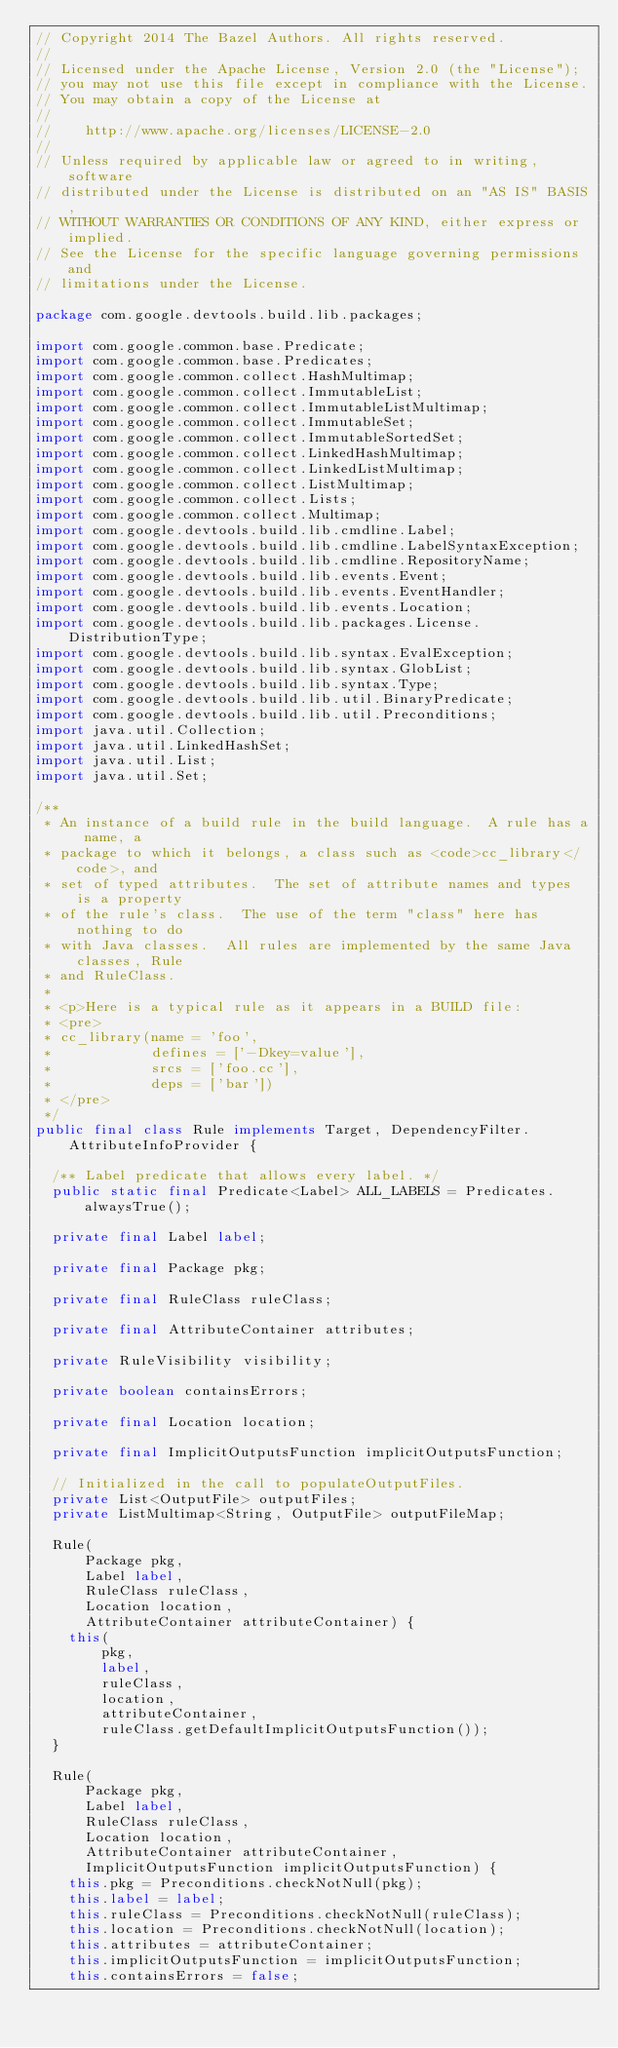Convert code to text. <code><loc_0><loc_0><loc_500><loc_500><_Java_>// Copyright 2014 The Bazel Authors. All rights reserved.
//
// Licensed under the Apache License, Version 2.0 (the "License");
// you may not use this file except in compliance with the License.
// You may obtain a copy of the License at
//
//    http://www.apache.org/licenses/LICENSE-2.0
//
// Unless required by applicable law or agreed to in writing, software
// distributed under the License is distributed on an "AS IS" BASIS,
// WITHOUT WARRANTIES OR CONDITIONS OF ANY KIND, either express or implied.
// See the License for the specific language governing permissions and
// limitations under the License.

package com.google.devtools.build.lib.packages;

import com.google.common.base.Predicate;
import com.google.common.base.Predicates;
import com.google.common.collect.HashMultimap;
import com.google.common.collect.ImmutableList;
import com.google.common.collect.ImmutableListMultimap;
import com.google.common.collect.ImmutableSet;
import com.google.common.collect.ImmutableSortedSet;
import com.google.common.collect.LinkedHashMultimap;
import com.google.common.collect.LinkedListMultimap;
import com.google.common.collect.ListMultimap;
import com.google.common.collect.Lists;
import com.google.common.collect.Multimap;
import com.google.devtools.build.lib.cmdline.Label;
import com.google.devtools.build.lib.cmdline.LabelSyntaxException;
import com.google.devtools.build.lib.cmdline.RepositoryName;
import com.google.devtools.build.lib.events.Event;
import com.google.devtools.build.lib.events.EventHandler;
import com.google.devtools.build.lib.events.Location;
import com.google.devtools.build.lib.packages.License.DistributionType;
import com.google.devtools.build.lib.syntax.EvalException;
import com.google.devtools.build.lib.syntax.GlobList;
import com.google.devtools.build.lib.syntax.Type;
import com.google.devtools.build.lib.util.BinaryPredicate;
import com.google.devtools.build.lib.util.Preconditions;
import java.util.Collection;
import java.util.LinkedHashSet;
import java.util.List;
import java.util.Set;

/**
 * An instance of a build rule in the build language.  A rule has a name, a
 * package to which it belongs, a class such as <code>cc_library</code>, and
 * set of typed attributes.  The set of attribute names and types is a property
 * of the rule's class.  The use of the term "class" here has nothing to do
 * with Java classes.  All rules are implemented by the same Java classes, Rule
 * and RuleClass.
 *
 * <p>Here is a typical rule as it appears in a BUILD file:
 * <pre>
 * cc_library(name = 'foo',
 *            defines = ['-Dkey=value'],
 *            srcs = ['foo.cc'],
 *            deps = ['bar'])
 * </pre>
 */
public final class Rule implements Target, DependencyFilter.AttributeInfoProvider {

  /** Label predicate that allows every label. */
  public static final Predicate<Label> ALL_LABELS = Predicates.alwaysTrue();

  private final Label label;

  private final Package pkg;

  private final RuleClass ruleClass;

  private final AttributeContainer attributes;

  private RuleVisibility visibility;

  private boolean containsErrors;

  private final Location location;

  private final ImplicitOutputsFunction implicitOutputsFunction;

  // Initialized in the call to populateOutputFiles.
  private List<OutputFile> outputFiles;
  private ListMultimap<String, OutputFile> outputFileMap;

  Rule(
      Package pkg,
      Label label,
      RuleClass ruleClass,
      Location location,
      AttributeContainer attributeContainer) {
    this(
        pkg,
        label,
        ruleClass,
        location,
        attributeContainer,
        ruleClass.getDefaultImplicitOutputsFunction());
  }

  Rule(
      Package pkg,
      Label label,
      RuleClass ruleClass,
      Location location,
      AttributeContainer attributeContainer,
      ImplicitOutputsFunction implicitOutputsFunction) {
    this.pkg = Preconditions.checkNotNull(pkg);
    this.label = label;
    this.ruleClass = Preconditions.checkNotNull(ruleClass);
    this.location = Preconditions.checkNotNull(location);
    this.attributes = attributeContainer;
    this.implicitOutputsFunction = implicitOutputsFunction;
    this.containsErrors = false;</code> 